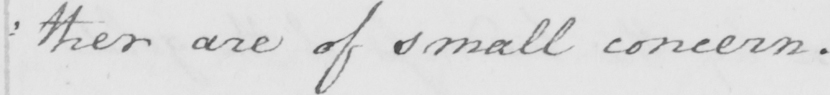Please provide the text content of this handwritten line. : ther are of small concern . 